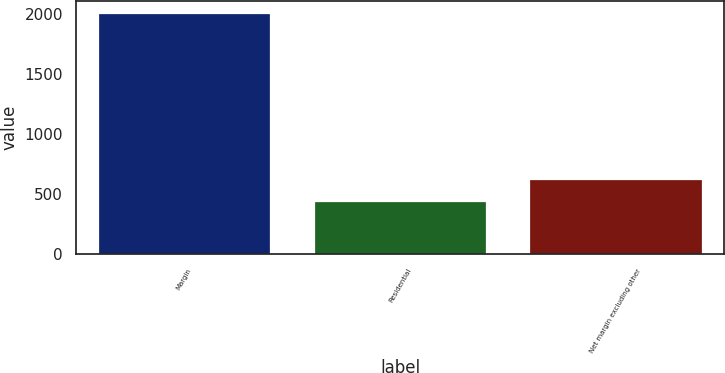Convert chart. <chart><loc_0><loc_0><loc_500><loc_500><bar_chart><fcel>Margin<fcel>Residential<fcel>Net margin excluding other<nl><fcel>2007<fcel>440.9<fcel>628.2<nl></chart> 